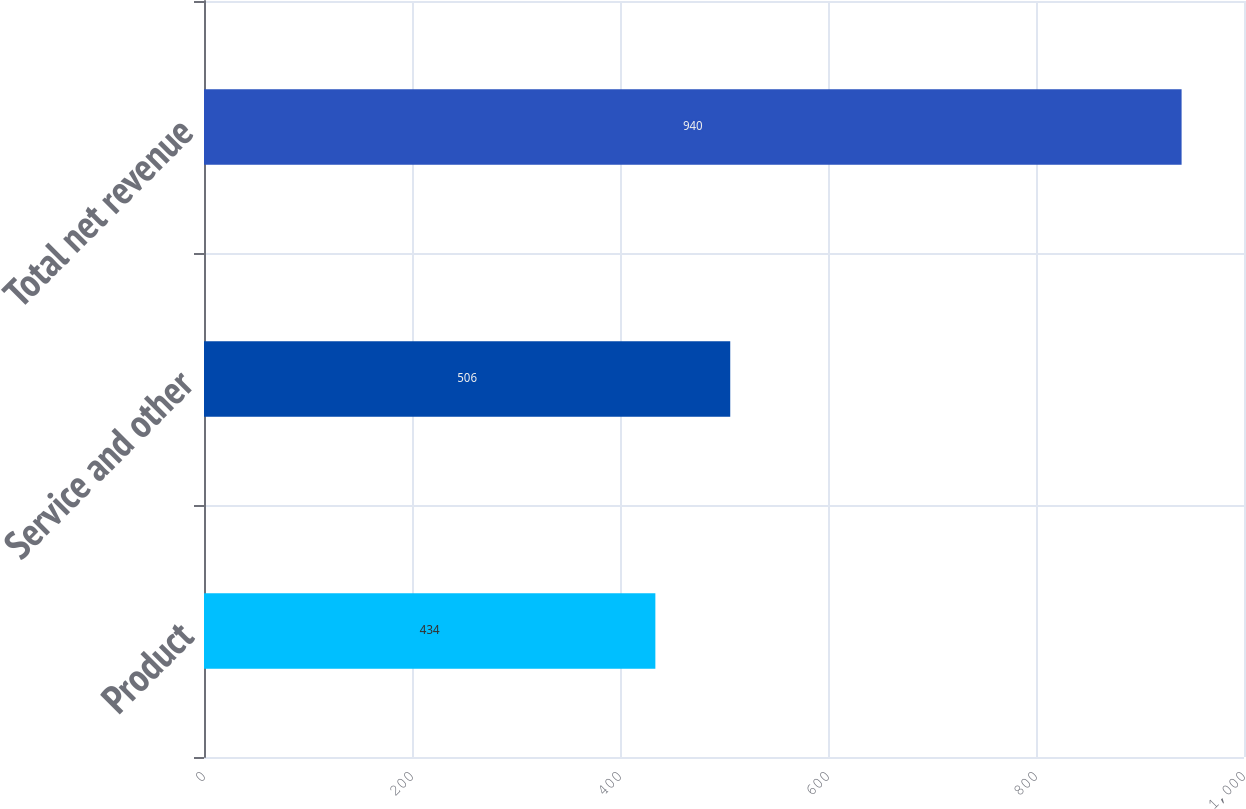<chart> <loc_0><loc_0><loc_500><loc_500><bar_chart><fcel>Product<fcel>Service and other<fcel>Total net revenue<nl><fcel>434<fcel>506<fcel>940<nl></chart> 